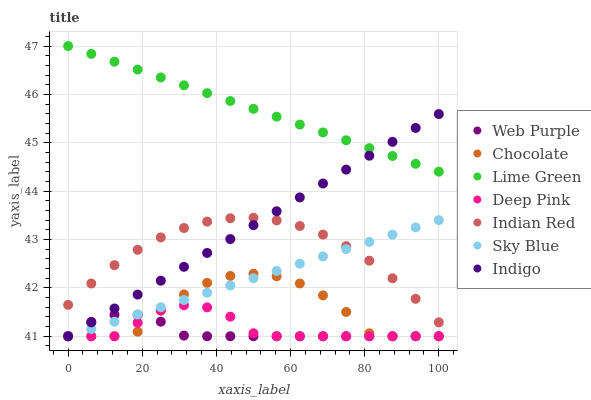Does Web Purple have the minimum area under the curve?
Answer yes or no. Yes. Does Lime Green have the maximum area under the curve?
Answer yes or no. Yes. Does Indigo have the minimum area under the curve?
Answer yes or no. No. Does Indigo have the maximum area under the curve?
Answer yes or no. No. Is Indigo the smoothest?
Answer yes or no. Yes. Is Chocolate the roughest?
Answer yes or no. Yes. Is Chocolate the smoothest?
Answer yes or no. No. Is Indigo the roughest?
Answer yes or no. No. Does Deep Pink have the lowest value?
Answer yes or no. Yes. Does Indian Red have the lowest value?
Answer yes or no. No. Does Lime Green have the highest value?
Answer yes or no. Yes. Does Indigo have the highest value?
Answer yes or no. No. Is Indian Red less than Lime Green?
Answer yes or no. Yes. Is Lime Green greater than Deep Pink?
Answer yes or no. Yes. Does Web Purple intersect Chocolate?
Answer yes or no. Yes. Is Web Purple less than Chocolate?
Answer yes or no. No. Is Web Purple greater than Chocolate?
Answer yes or no. No. Does Indian Red intersect Lime Green?
Answer yes or no. No. 